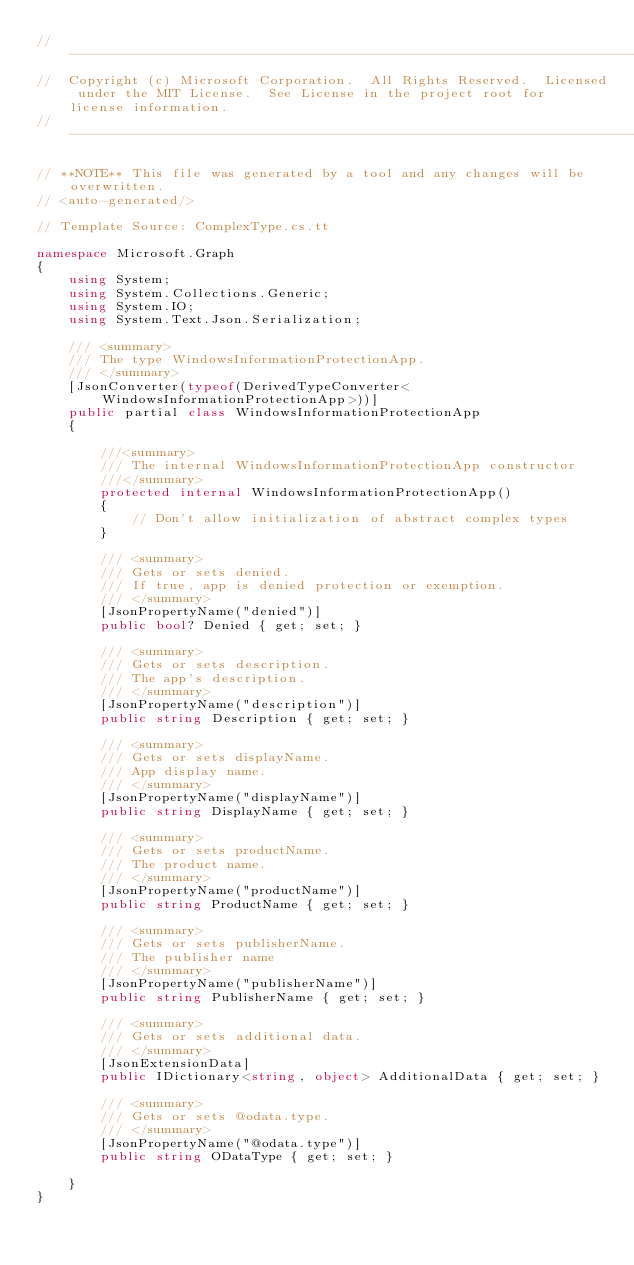Convert code to text. <code><loc_0><loc_0><loc_500><loc_500><_C#_>// ------------------------------------------------------------------------------
//  Copyright (c) Microsoft Corporation.  All Rights Reserved.  Licensed under the MIT License.  See License in the project root for license information.
// ------------------------------------------------------------------------------

// **NOTE** This file was generated by a tool and any changes will be overwritten.
// <auto-generated/>

// Template Source: ComplexType.cs.tt

namespace Microsoft.Graph
{
    using System;
    using System.Collections.Generic;
    using System.IO;
    using System.Text.Json.Serialization;

    /// <summary>
    /// The type WindowsInformationProtectionApp.
    /// </summary>
    [JsonConverter(typeof(DerivedTypeConverter<WindowsInformationProtectionApp>))]
    public partial class WindowsInformationProtectionApp
    {

        ///<summary>
        /// The internal WindowsInformationProtectionApp constructor
        ///</summary>
        protected internal WindowsInformationProtectionApp()
        {
            // Don't allow initialization of abstract complex types
        }

        /// <summary>
        /// Gets or sets denied.
        /// If true, app is denied protection or exemption.
        /// </summary>
        [JsonPropertyName("denied")]
        public bool? Denied { get; set; }
    
        /// <summary>
        /// Gets or sets description.
        /// The app's description.
        /// </summary>
        [JsonPropertyName("description")]
        public string Description { get; set; }
    
        /// <summary>
        /// Gets or sets displayName.
        /// App display name.
        /// </summary>
        [JsonPropertyName("displayName")]
        public string DisplayName { get; set; }
    
        /// <summary>
        /// Gets or sets productName.
        /// The product name.
        /// </summary>
        [JsonPropertyName("productName")]
        public string ProductName { get; set; }
    
        /// <summary>
        /// Gets or sets publisherName.
        /// The publisher name
        /// </summary>
        [JsonPropertyName("publisherName")]
        public string PublisherName { get; set; }
    
        /// <summary>
        /// Gets or sets additional data.
        /// </summary>
        [JsonExtensionData]
        public IDictionary<string, object> AdditionalData { get; set; }

        /// <summary>
        /// Gets or sets @odata.type.
        /// </summary>
        [JsonPropertyName("@odata.type")]
        public string ODataType { get; set; }
    
    }
}
</code> 